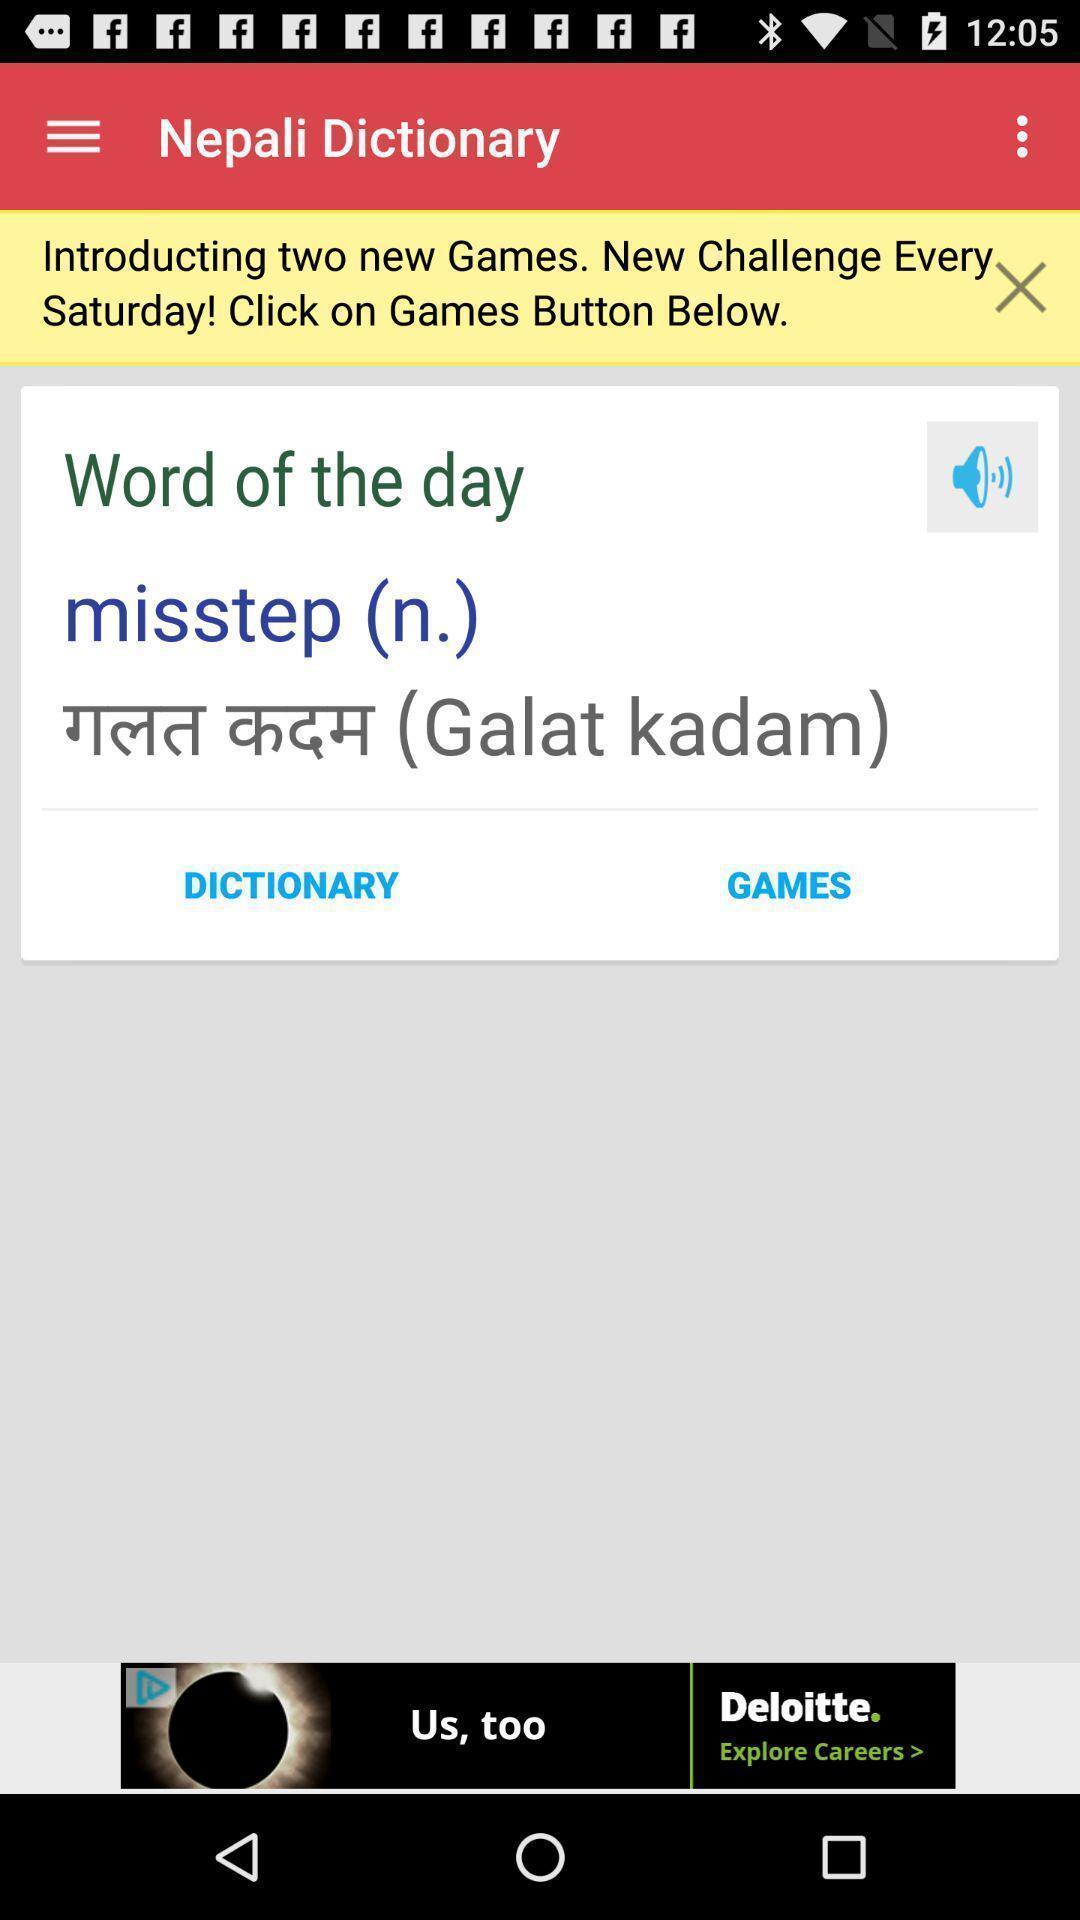Give me a narrative description of this picture. Window displaying a dictionary app. 